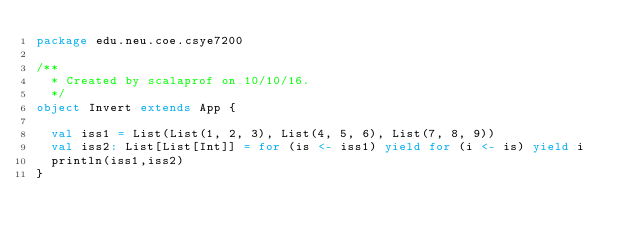<code> <loc_0><loc_0><loc_500><loc_500><_Scala_>package edu.neu.coe.csye7200

/**
  * Created by scalaprof on 10/10/16.
  */
object Invert extends App {

  val iss1 = List(List(1, 2, 3), List(4, 5, 6), List(7, 8, 9))
  val iss2: List[List[Int]] = for (is <- iss1) yield for (i <- is) yield i
  println(iss1,iss2)
}
</code> 